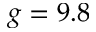<formula> <loc_0><loc_0><loc_500><loc_500>g = 9 . 8</formula> 